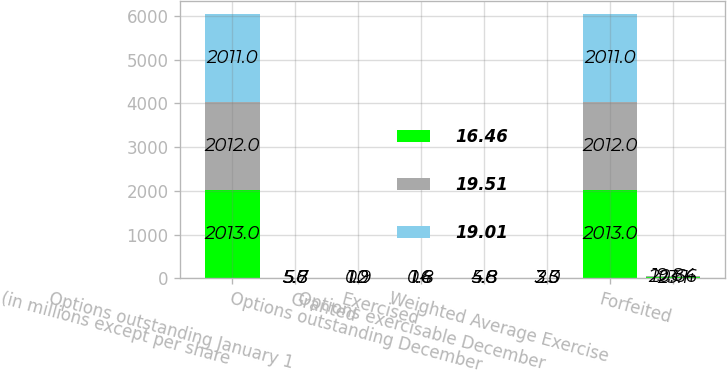Convert chart. <chart><loc_0><loc_0><loc_500><loc_500><stacked_bar_chart><ecel><fcel>(in millions except per share<fcel>Options outstanding January 1<fcel>Granted<fcel>Exercised<fcel>Options outstanding December<fcel>Options exercisable December<fcel>Weighted Average Exercise<fcel>Forfeited<nl><fcel>16.46<fcel>2013<fcel>5.6<fcel>0.9<fcel>1.6<fcel>4.8<fcel>2.3<fcel>2013<fcel>23.1<nl><fcel>19.51<fcel>2012<fcel>5.8<fcel>1.2<fcel>1.4<fcel>5.6<fcel>3<fcel>2012<fcel>20.66<nl><fcel>19.01<fcel>2011<fcel>5.7<fcel>1<fcel>0.8<fcel>5.8<fcel>3.5<fcel>2011<fcel>19.84<nl></chart> 